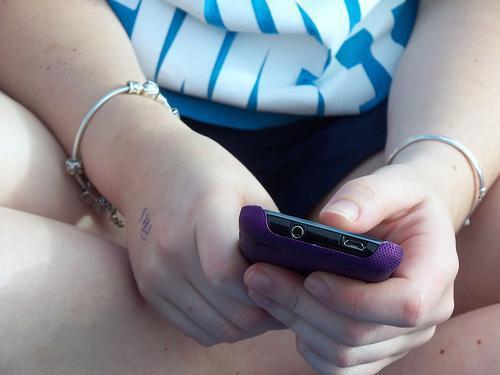How many phones are there?
Give a very brief answer. 1. 